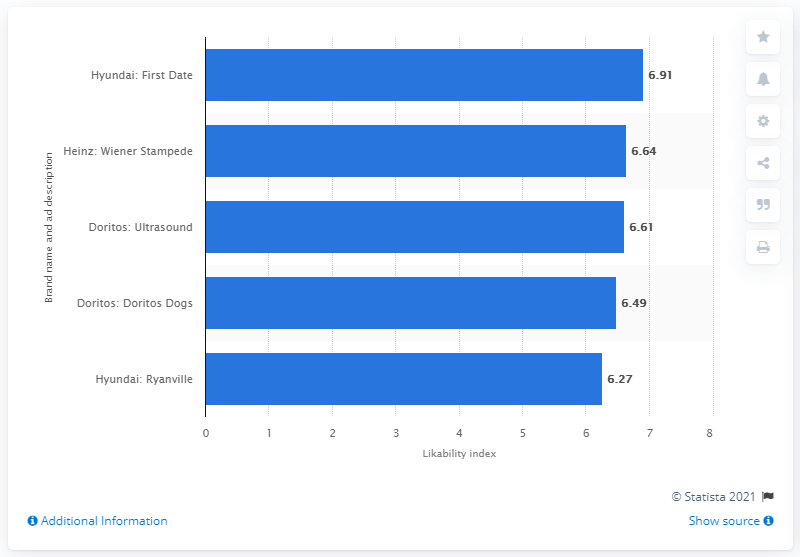Indicate a few pertinent items in this graphic. The likability index score for the first date commercial was 6.91. 